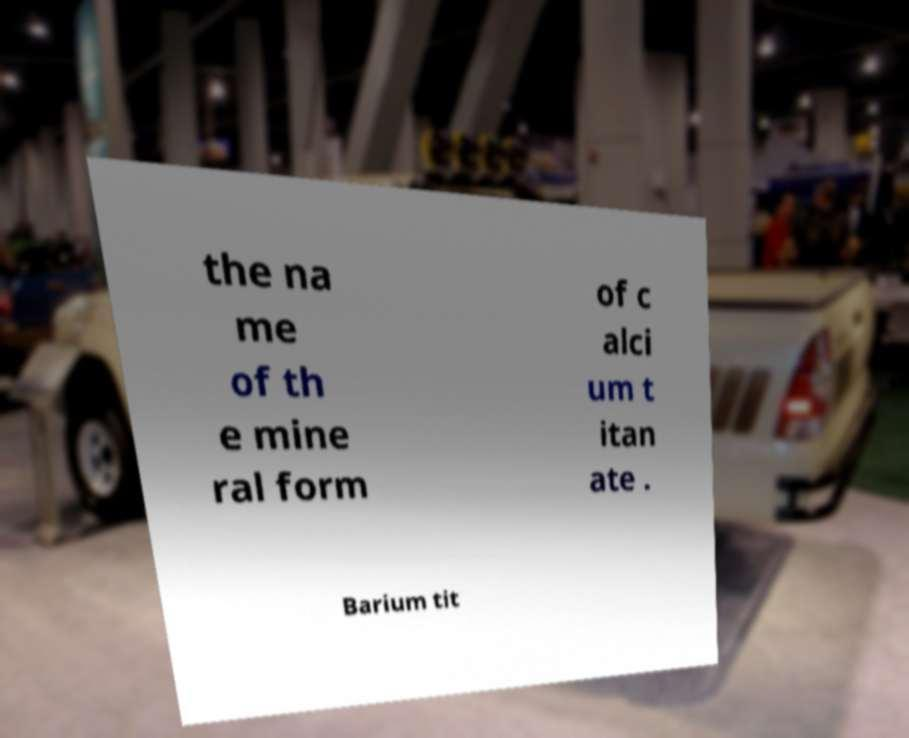Can you read and provide the text displayed in the image?This photo seems to have some interesting text. Can you extract and type it out for me? the na me of th e mine ral form of c alci um t itan ate . Barium tit 